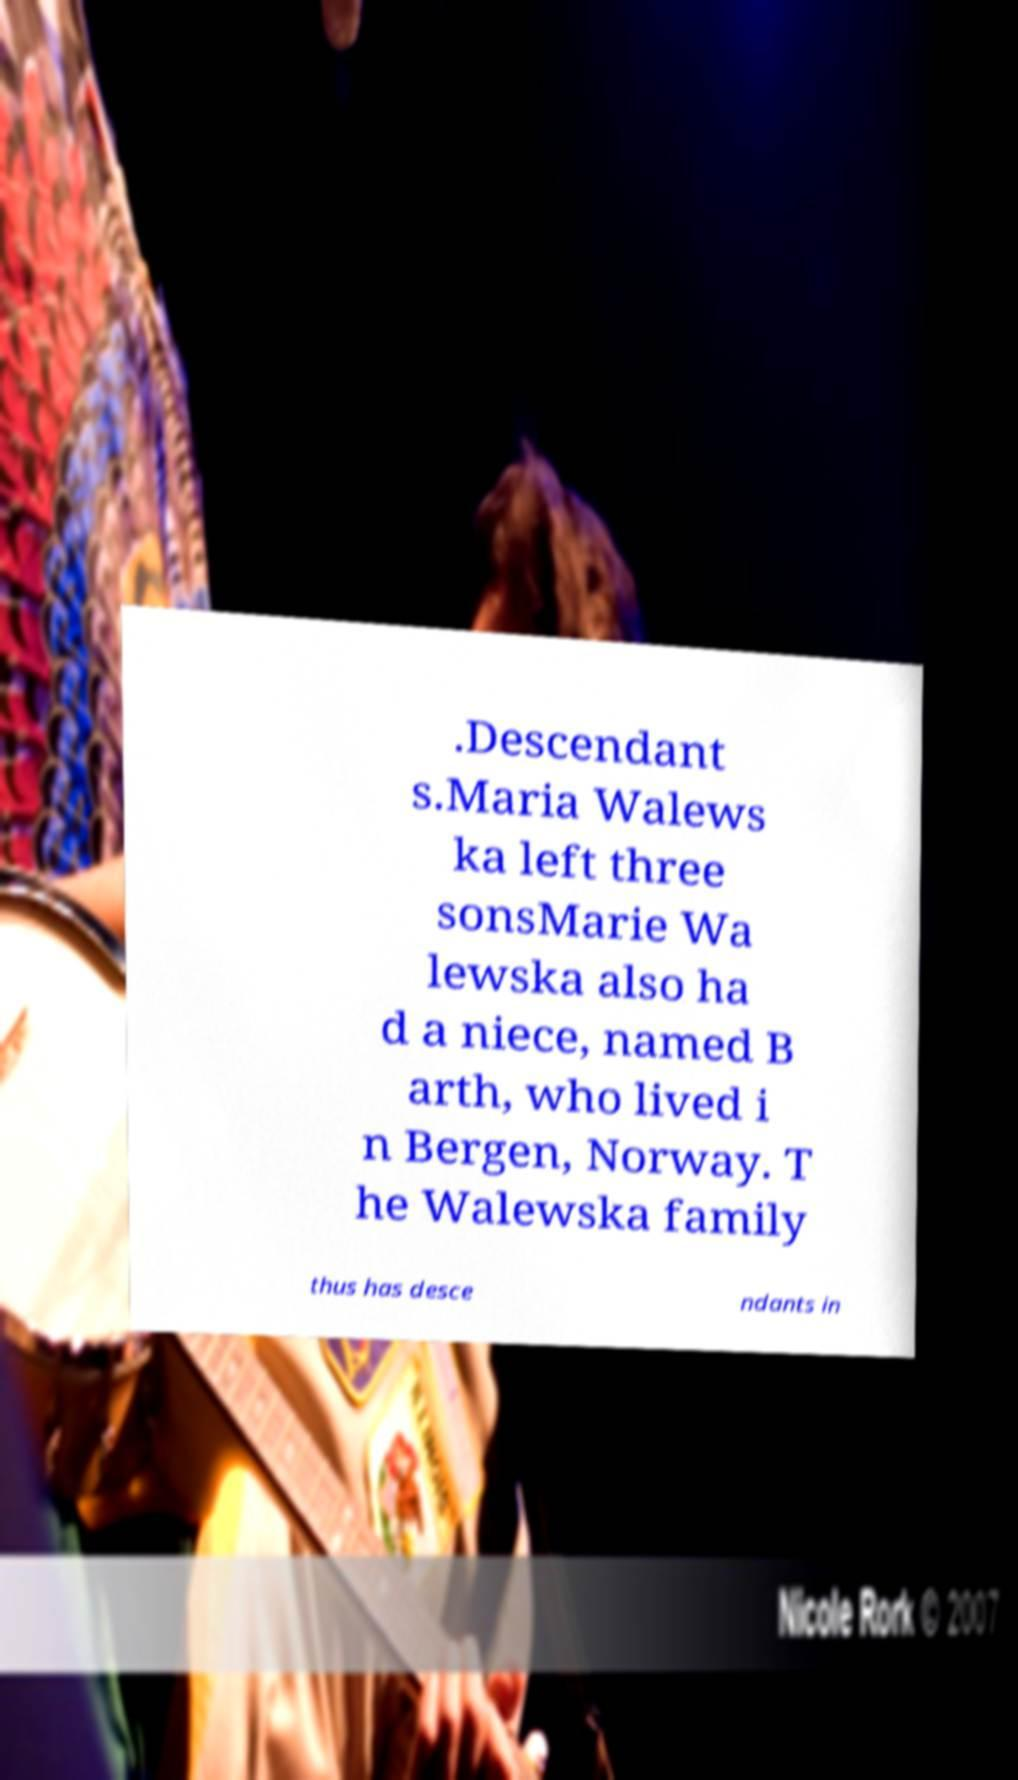Please identify and transcribe the text found in this image. .Descendant s.Maria Walews ka left three sonsMarie Wa lewska also ha d a niece, named B arth, who lived i n Bergen, Norway. T he Walewska family thus has desce ndants in 